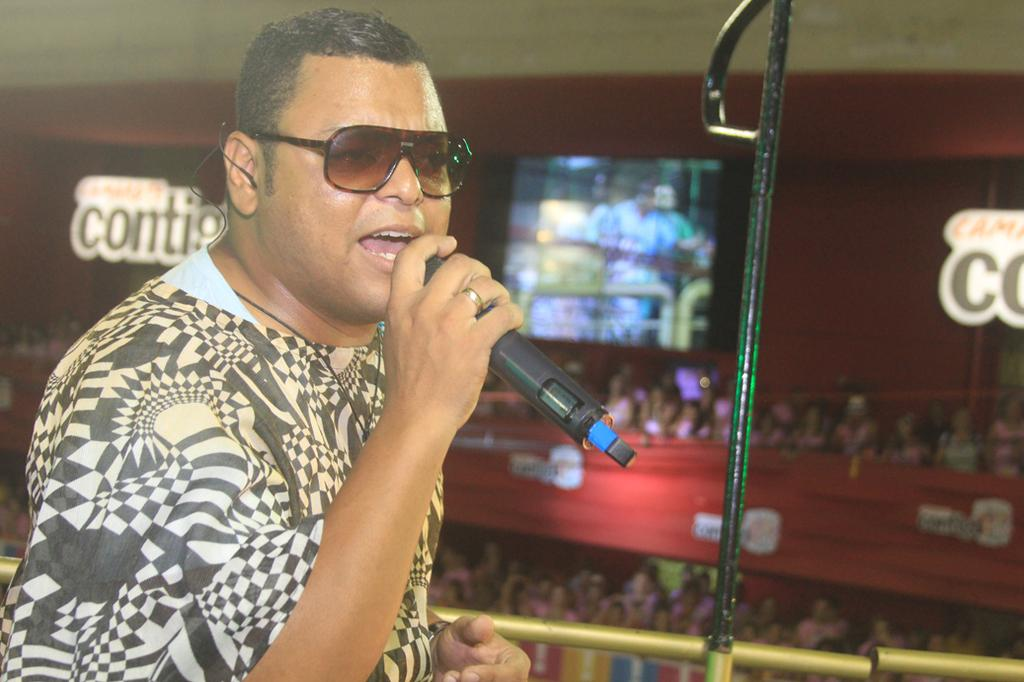What is the main subject of the image? There is a person in the image. What object is the person holding in the image? There is a microphone in the image. What type of material are the rods made of in the image? The metal rods are made of metal in the image. Can you describe the background of the image? The background of the image is blurred. What type of punishment is being administered to the cat in the image? There is no cat present in the image, and therefore no punishment is being administered. 